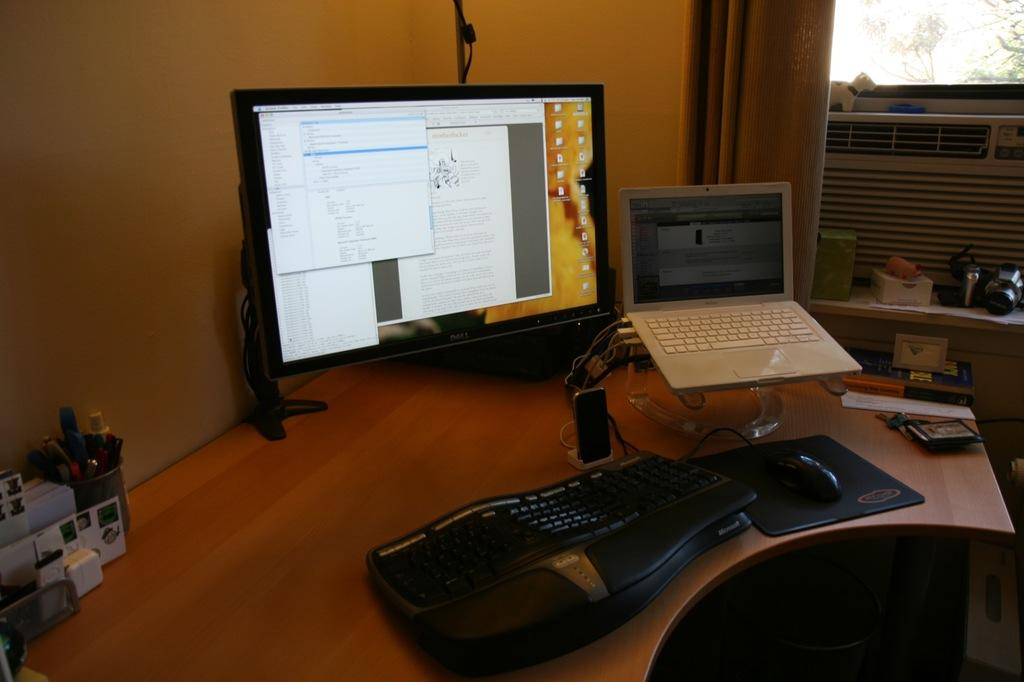What electronic device is the main focus of the image? There is a computer screen in the image. What other device is present in the image? There is a laptop in the image. What accessory is used to interact with the computer? There is a keyboard and a mouse in the image. What can be seen in the background of the image? In the background, there is a wall and a curtain. What hobbies are the sheep engaging in while sitting on the keyboard in the image? There are no sheep present in the image, so it is not possible to answer that question. 